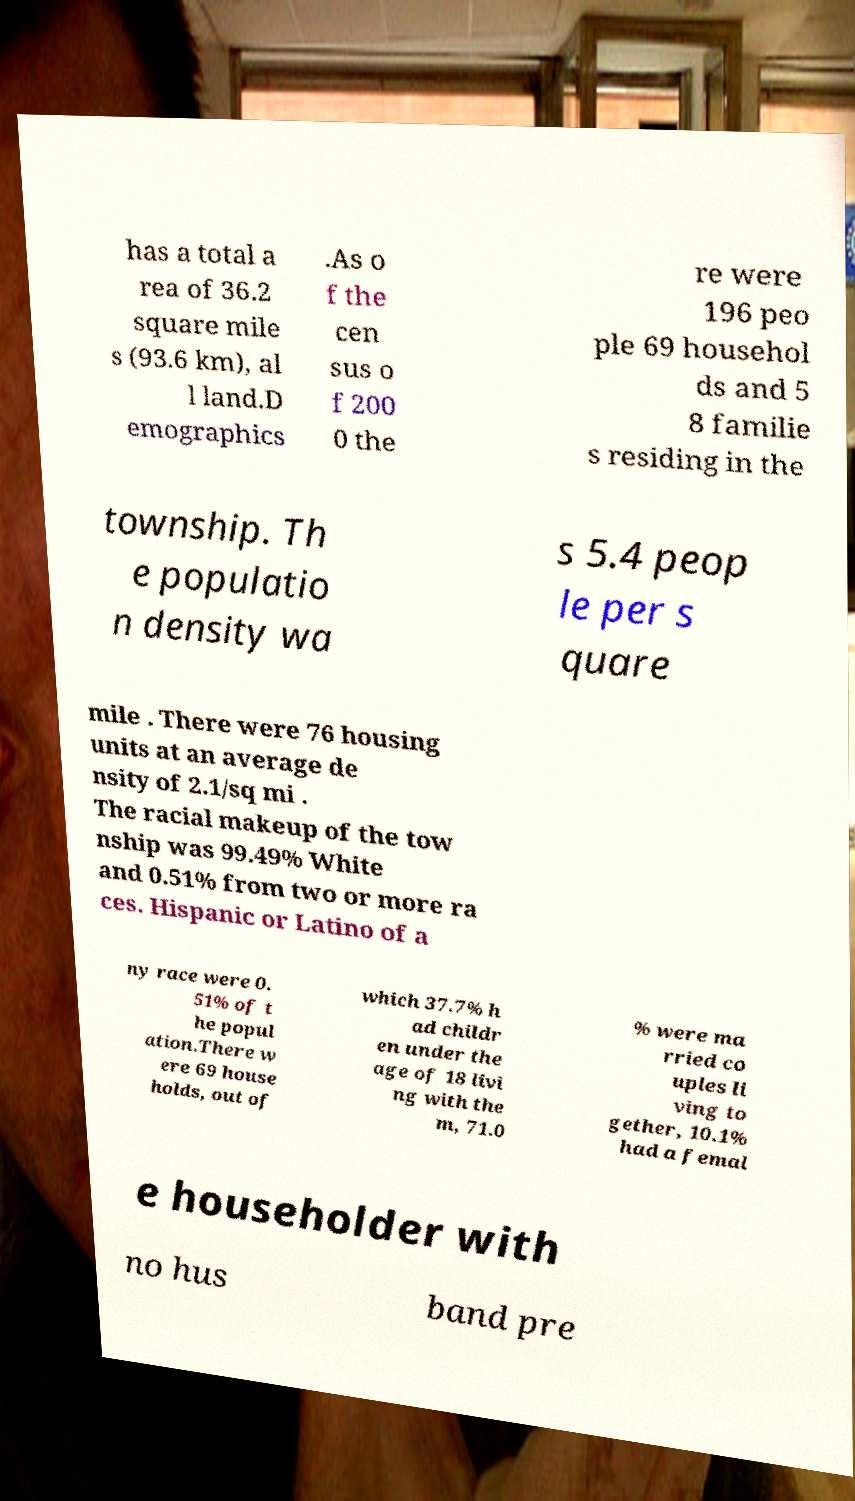For documentation purposes, I need the text within this image transcribed. Could you provide that? has a total a rea of 36.2 square mile s (93.6 km), al l land.D emographics .As o f the cen sus o f 200 0 the re were 196 peo ple 69 househol ds and 5 8 familie s residing in the township. Th e populatio n density wa s 5.4 peop le per s quare mile . There were 76 housing units at an average de nsity of 2.1/sq mi . The racial makeup of the tow nship was 99.49% White and 0.51% from two or more ra ces. Hispanic or Latino of a ny race were 0. 51% of t he popul ation.There w ere 69 house holds, out of which 37.7% h ad childr en under the age of 18 livi ng with the m, 71.0 % were ma rried co uples li ving to gether, 10.1% had a femal e householder with no hus band pre 